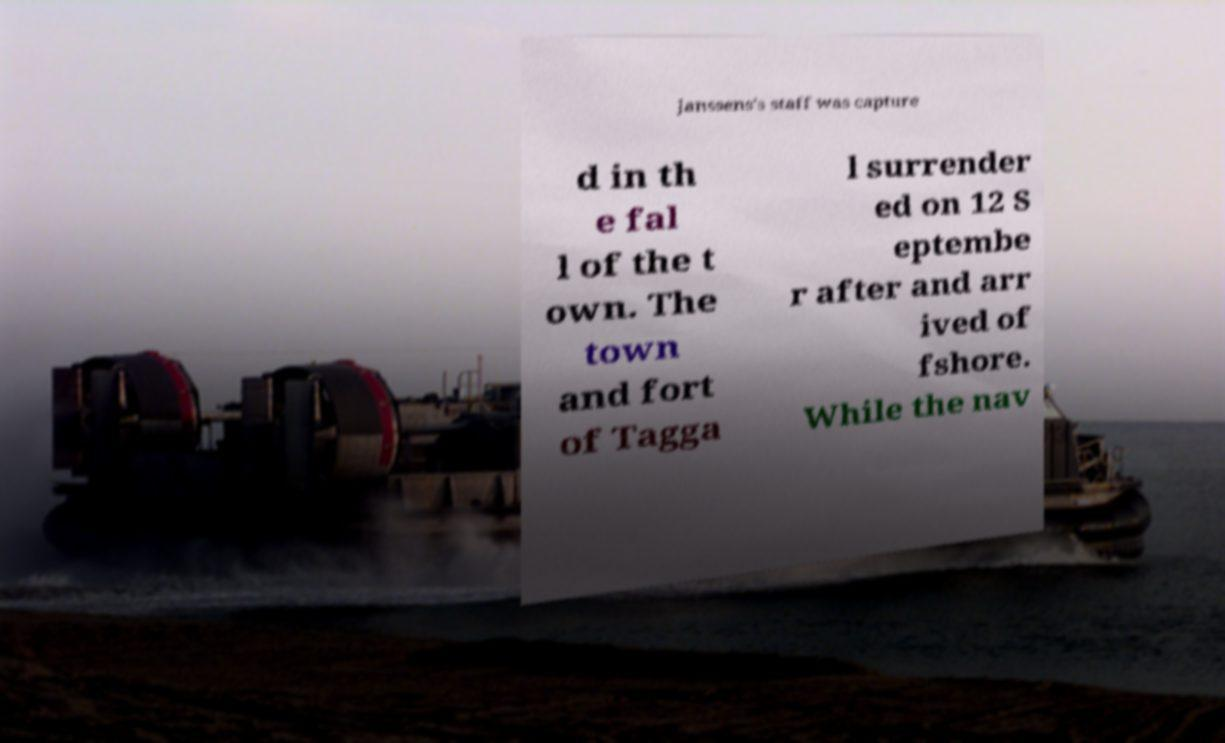Could you extract and type out the text from this image? Janssens's staff was capture d in th e fal l of the t own. The town and fort of Tagga l surrender ed on 12 S eptembe r after and arr ived of fshore. While the nav 